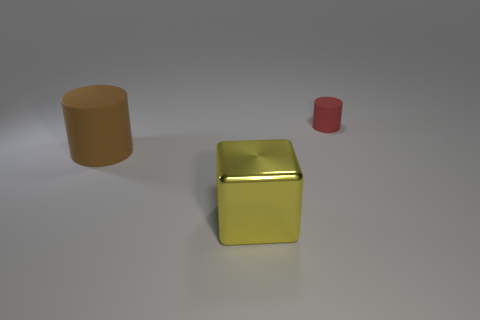Is there any other thing that has the same size as the red cylinder?
Provide a short and direct response. No. How many rubber objects are big cylinders or big red blocks?
Provide a short and direct response. 1. There is a large yellow thing that is in front of the thing that is behind the matte cylinder that is to the left of the small rubber cylinder; what is its material?
Provide a short and direct response. Metal. There is a object that is behind the matte object that is in front of the tiny cylinder; what is its color?
Your response must be concise. Red. What number of small objects are either matte things or yellow objects?
Offer a very short reply. 1. How many big brown cylinders are made of the same material as the red thing?
Make the answer very short. 1. How big is the matte cylinder right of the brown matte cylinder?
Make the answer very short. Small. The matte object right of the rubber cylinder in front of the tiny red rubber cylinder is what shape?
Give a very brief answer. Cylinder. There is a object that is behind the cylinder left of the big block; what number of objects are in front of it?
Provide a succinct answer. 2. Is the number of rubber cylinders right of the yellow block less than the number of objects?
Give a very brief answer. Yes. 